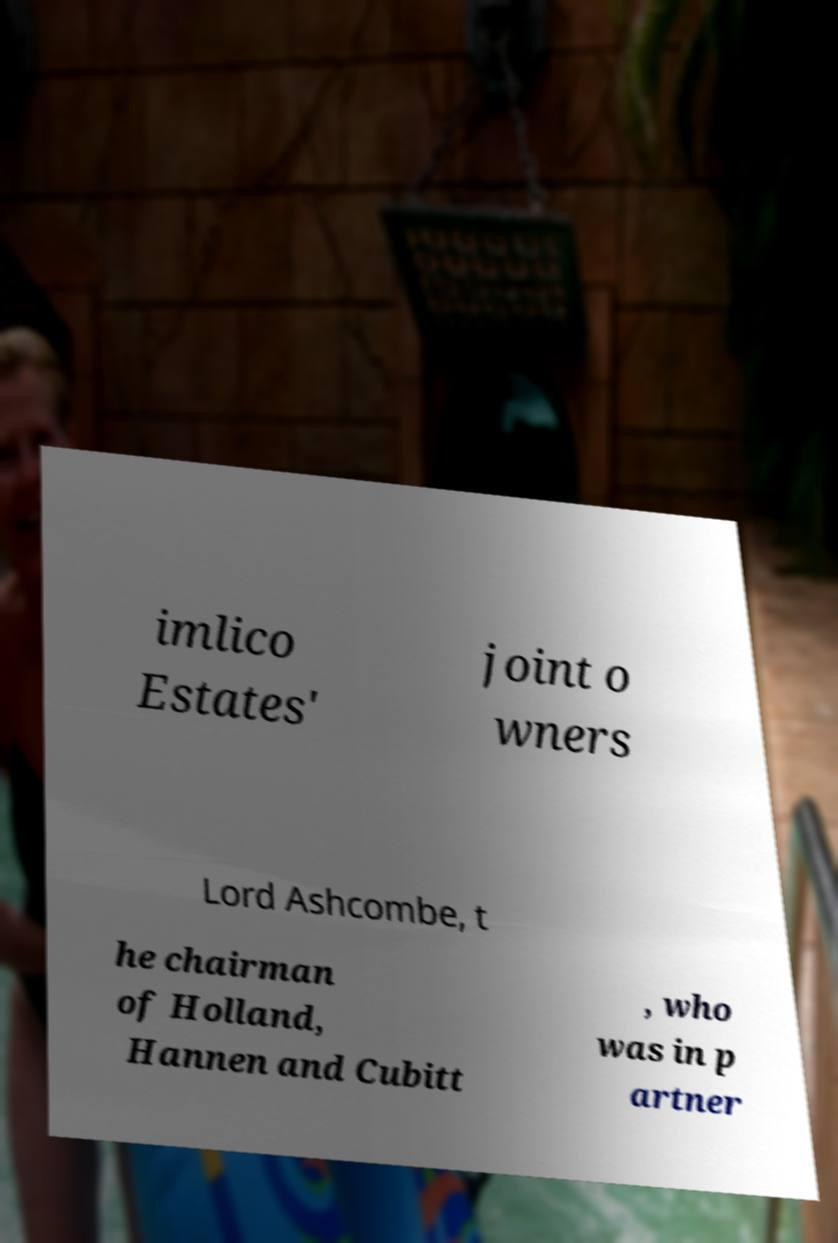For documentation purposes, I need the text within this image transcribed. Could you provide that? imlico Estates' joint o wners Lord Ashcombe, t he chairman of Holland, Hannen and Cubitt , who was in p artner 